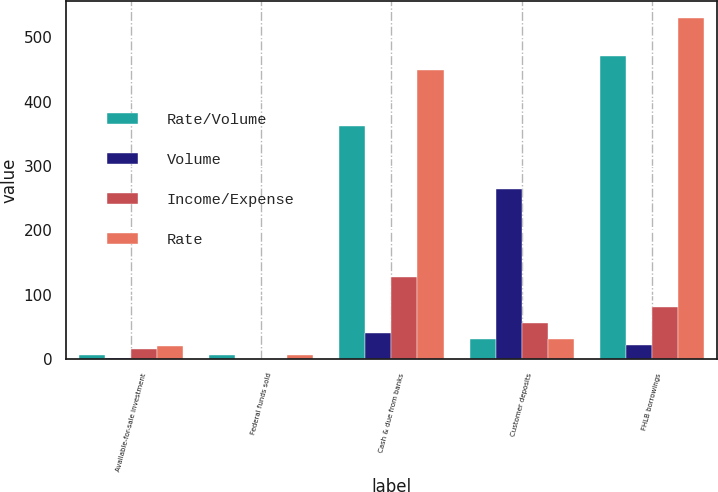Convert chart to OTSL. <chart><loc_0><loc_0><loc_500><loc_500><stacked_bar_chart><ecel><fcel>Available-for-sale investment<fcel>Federal funds sold<fcel>Cash & due from banks<fcel>Customer deposits<fcel>FHLB borrowings<nl><fcel>Rate/Volume<fcel>7<fcel>6<fcel>362<fcel>31<fcel>471<nl><fcel>Volume<fcel>2<fcel>1<fcel>40<fcel>264<fcel>22<nl><fcel>Income/Expense<fcel>16<fcel>1<fcel>128<fcel>56<fcel>81<nl><fcel>Rate<fcel>21<fcel>6<fcel>450<fcel>31<fcel>530<nl></chart> 